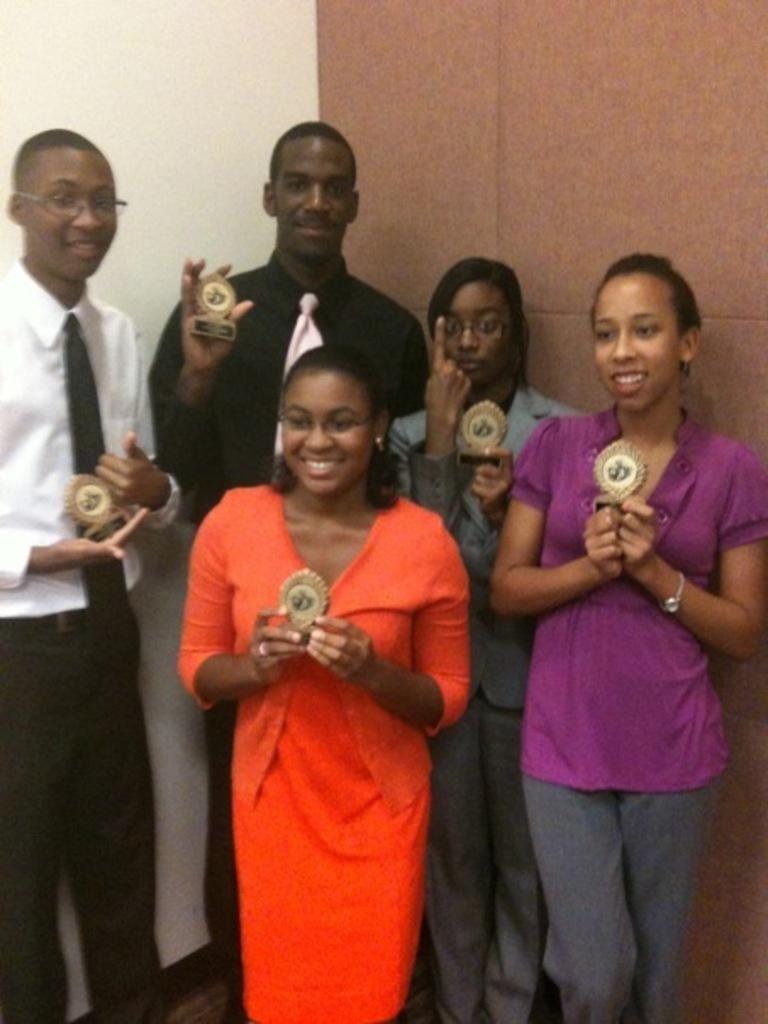What is happening in the image involving the group of people? The people in the image are standing and holding awards in their hands. What can be seen in the background of the image? There is a wall in the background of the image. What time of day is it in the image, and how does the group of people prepare for the morning test? The time of day is not mentioned in the image, and there is no mention of a morning test. The group of people is holding awards, not preparing for a test. 